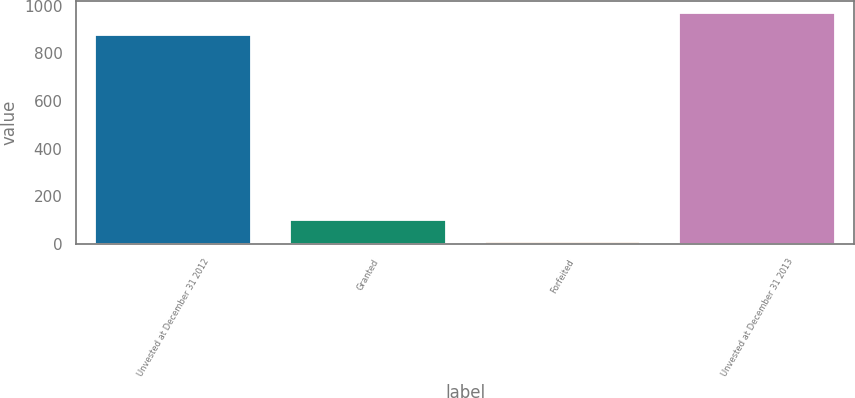Convert chart to OTSL. <chart><loc_0><loc_0><loc_500><loc_500><bar_chart><fcel>Unvested at December 31 2012<fcel>Granted<fcel>Forfeited<fcel>Unvested at December 31 2013<nl><fcel>878<fcel>99.7<fcel>8<fcel>969.7<nl></chart> 